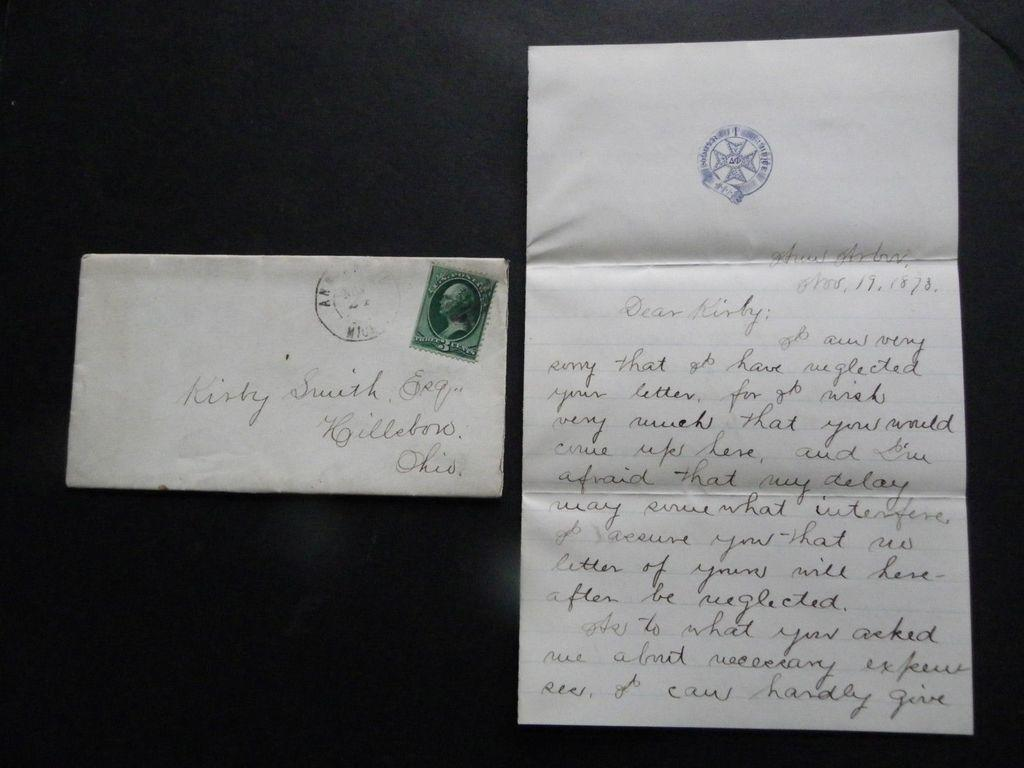<image>
Give a short and clear explanation of the subsequent image. A vintage letter was dated all the way back to 1878. 